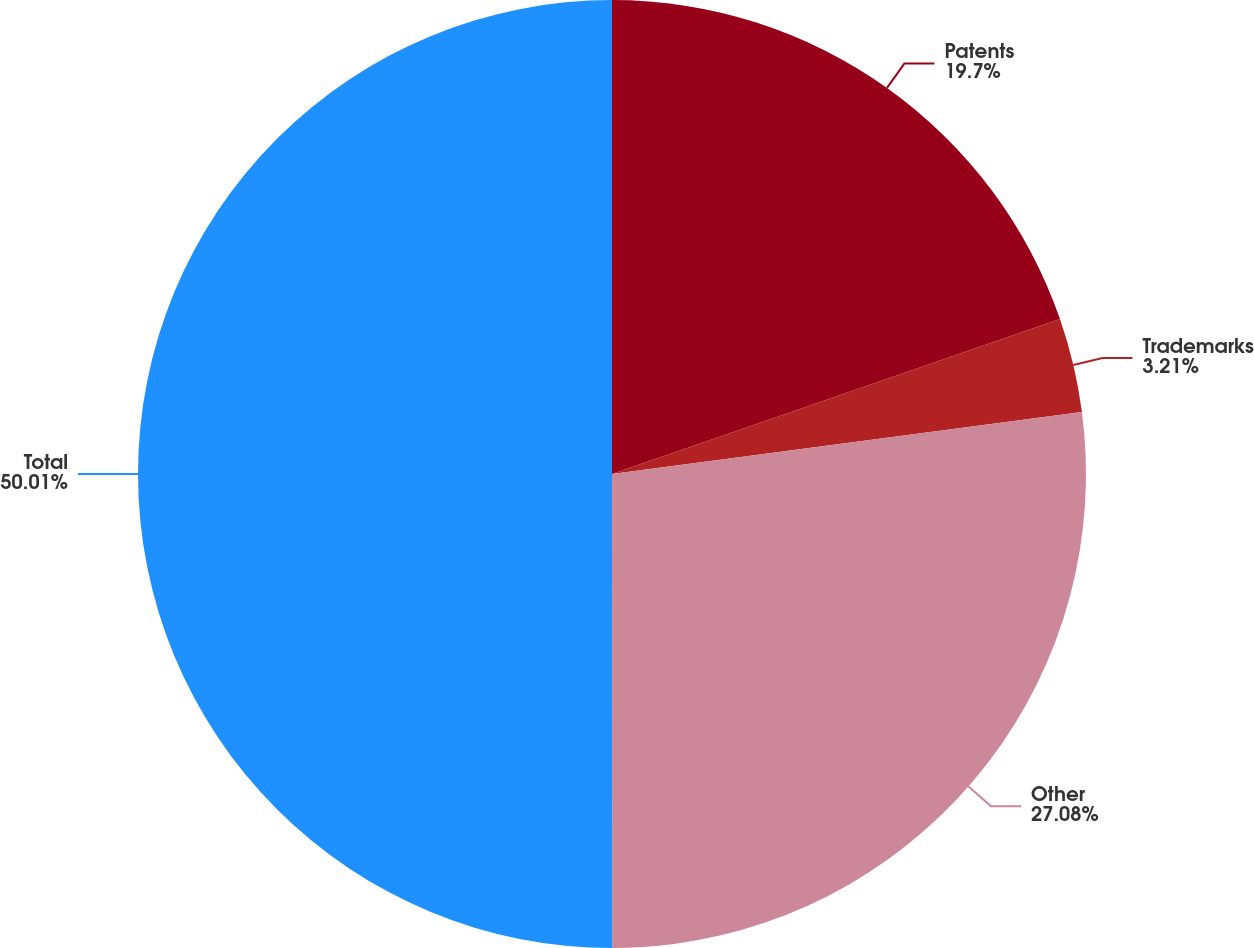<chart> <loc_0><loc_0><loc_500><loc_500><pie_chart><fcel>Patents<fcel>Trademarks<fcel>Other<fcel>Total<nl><fcel>19.7%<fcel>3.21%<fcel>27.08%<fcel>50.0%<nl></chart> 